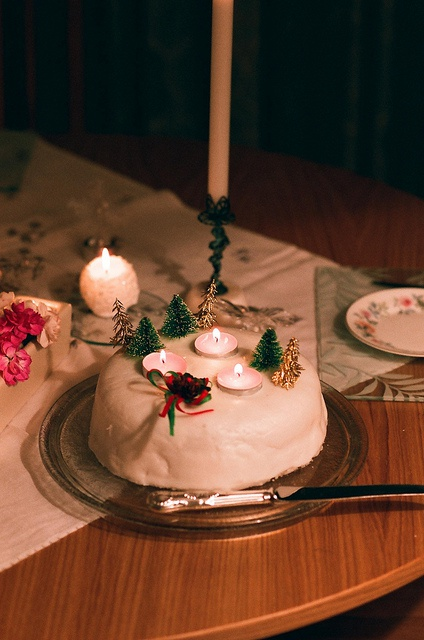Describe the objects in this image and their specific colors. I can see dining table in black, maroon, brown, and salmon tones, cake in black, tan, and salmon tones, and knife in black, maroon, brown, and salmon tones in this image. 